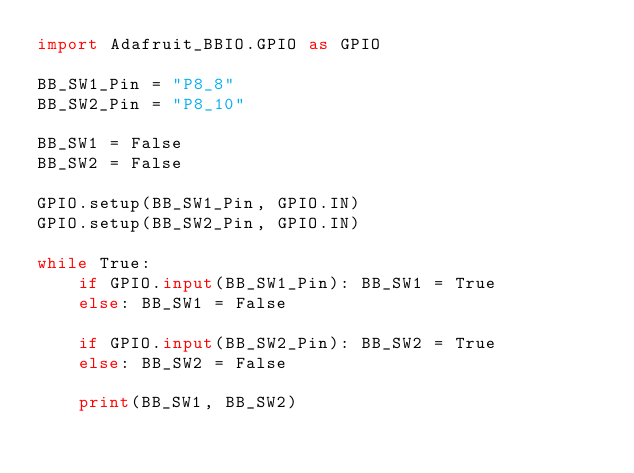<code> <loc_0><loc_0><loc_500><loc_500><_Python_>import Adafruit_BBIO.GPIO as GPIO

BB_SW1_Pin = "P8_8"
BB_SW2_Pin = "P8_10"

BB_SW1 = False
BB_SW2 = False

GPIO.setup(BB_SW1_Pin, GPIO.IN)
GPIO.setup(BB_SW2_Pin, GPIO.IN)

while True:
    if GPIO.input(BB_SW1_Pin): BB_SW1 = True
    else: BB_SW1 = False
    
    if GPIO.input(BB_SW2_Pin): BB_SW2 = True
    else: BB_SW2 = False

    print(BB_SW1, BB_SW2)
</code> 